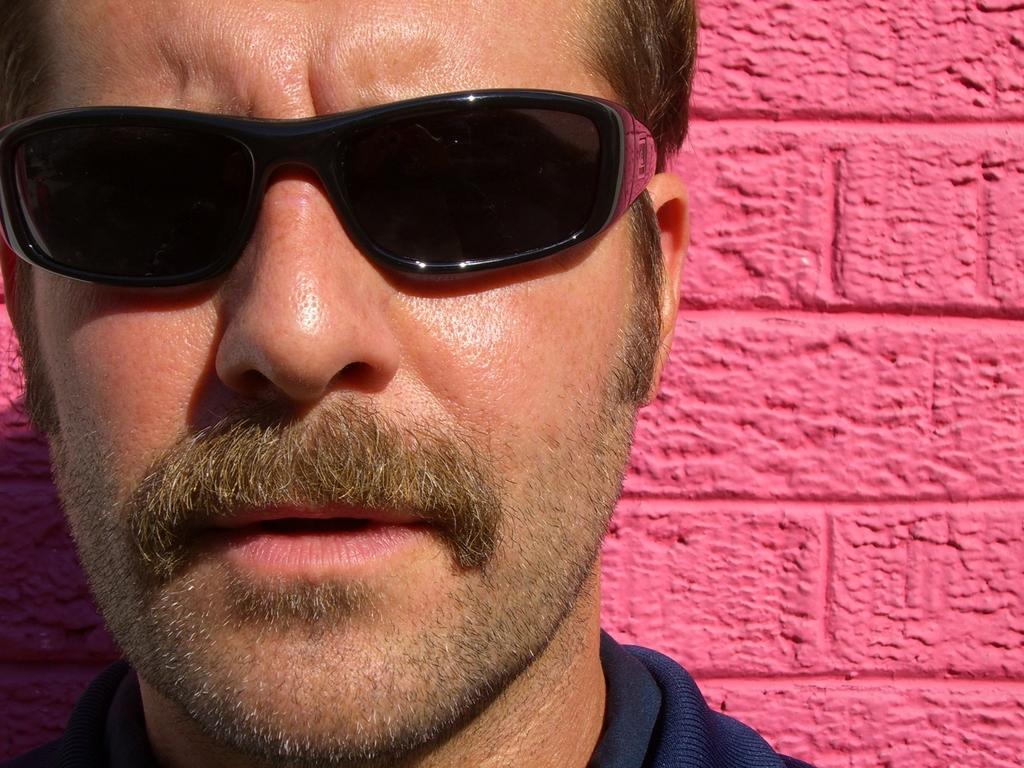How would you summarize this image in a sentence or two? In this picture we can observe a person. He is wearing black color spectacles. Behind him there is a pink color wall. 